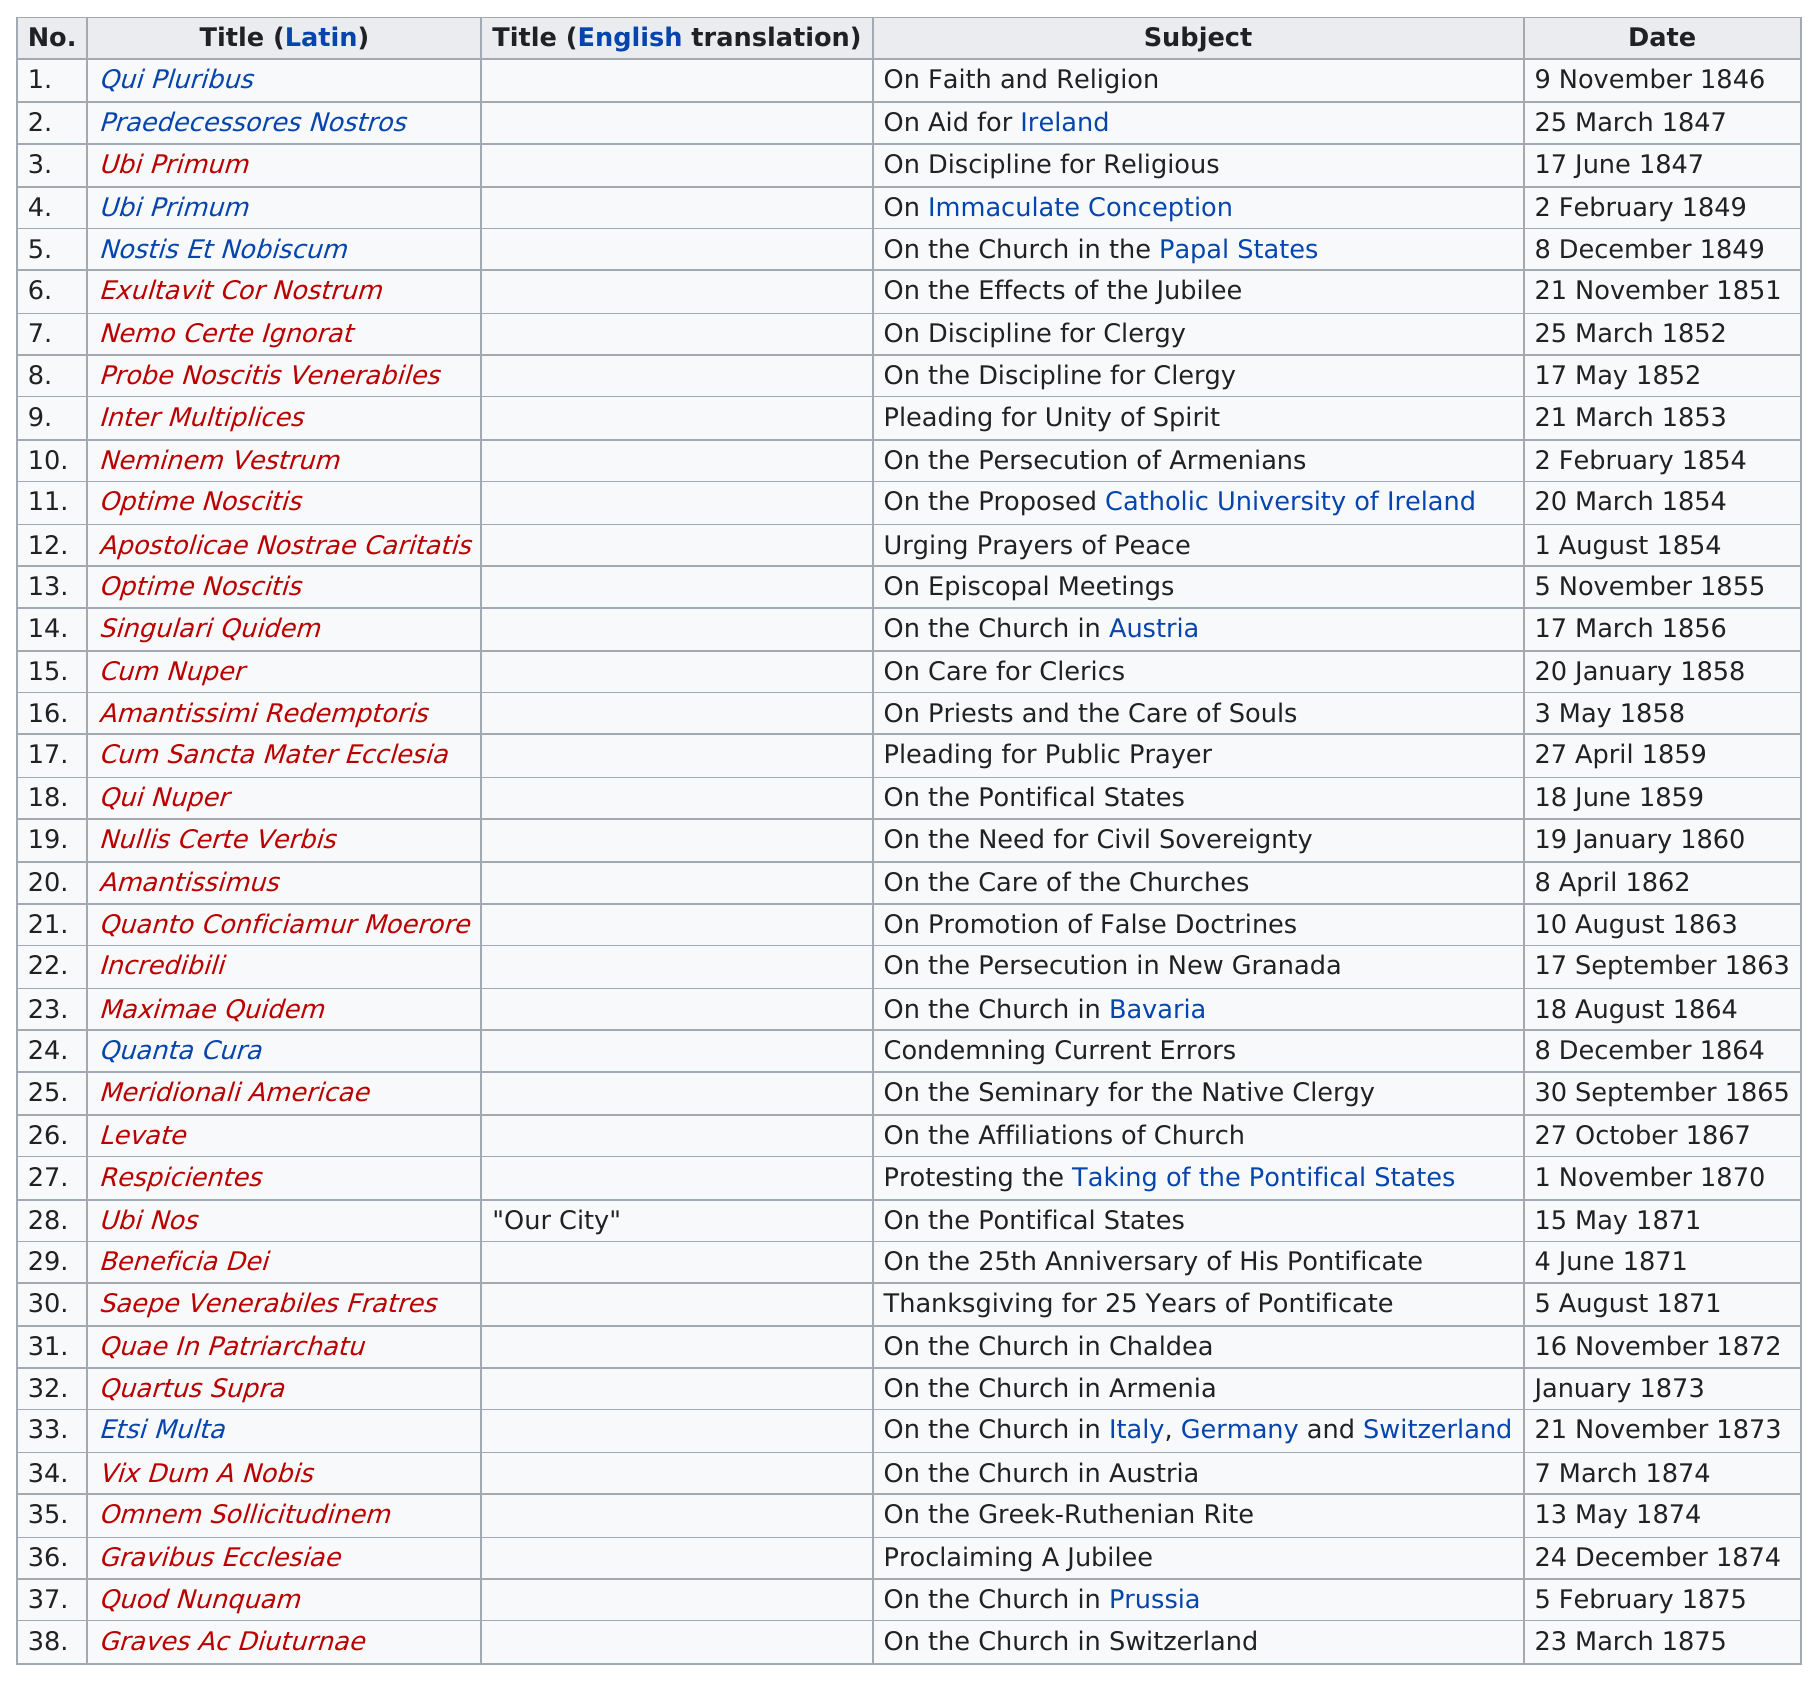List a handful of essential elements in this visual. According to my analysis, the Latin prefix "nos" appears a total of 7 times in the titles of encyclicals. The previous subject after "on the effects of the jubilee" is "On the Church in the Papal States. The most recent encyclical whose subject matter contained the word "pontificate" was issued on August 5, 1871. The last title is "Graves Ac Diuturnae...". There have been a total of 11 encyclicals issued on the Catholic Church. 